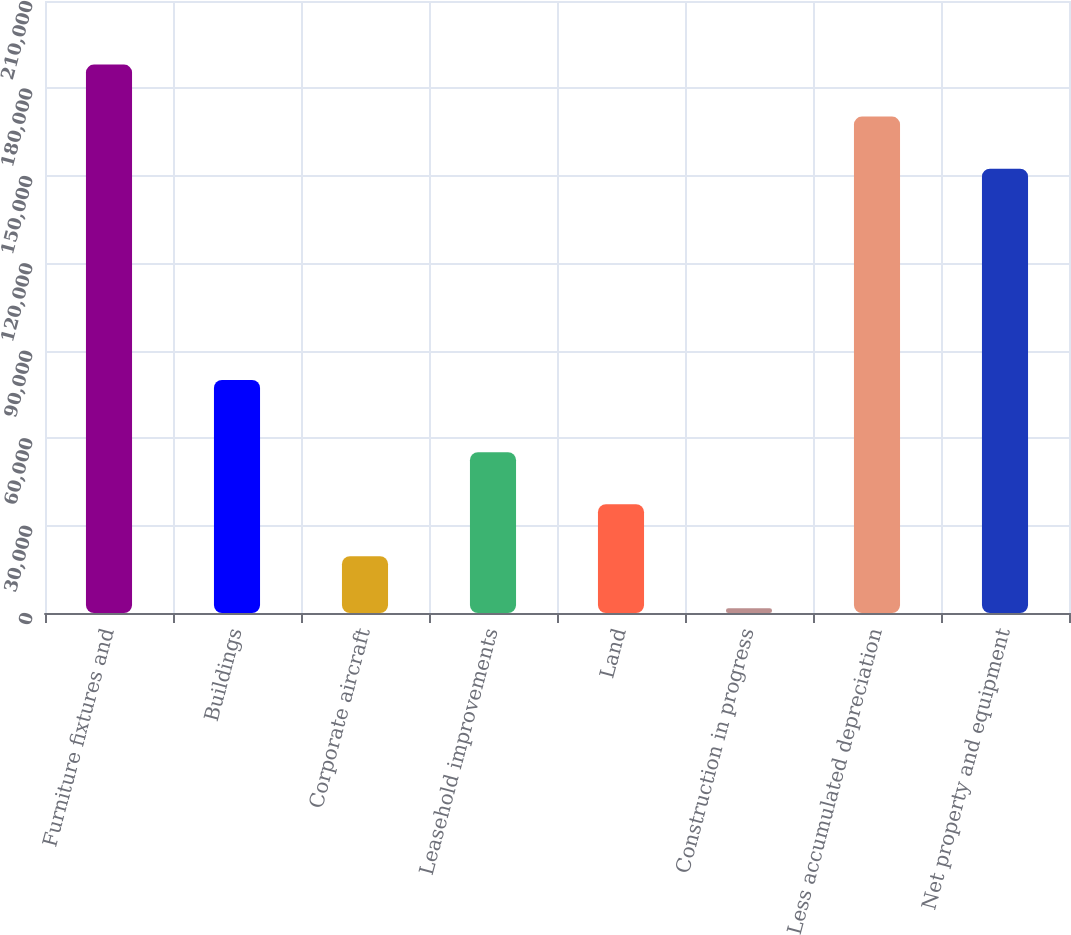<chart> <loc_0><loc_0><loc_500><loc_500><bar_chart><fcel>Furniture fixtures and<fcel>Buildings<fcel>Corporate aircraft<fcel>Leasehold improvements<fcel>Land<fcel>Construction in progress<fcel>Less accumulated depreciation<fcel>Net property and equipment<nl><fcel>188195<fcel>79981<fcel>19474.1<fcel>55198.3<fcel>37336.2<fcel>1612<fcel>170333<fcel>152471<nl></chart> 